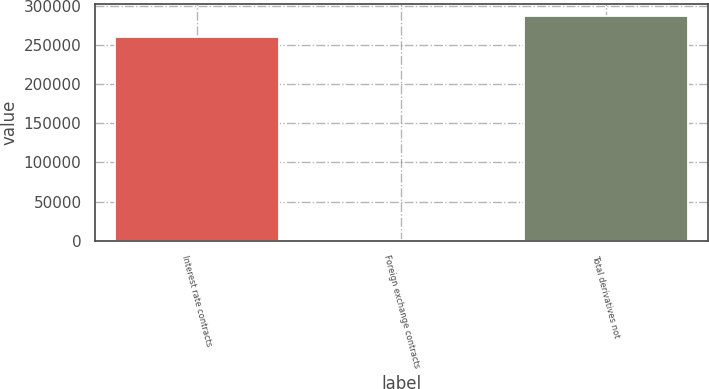<chart> <loc_0><loc_0><loc_500><loc_500><bar_chart><fcel>Interest rate contracts<fcel>Foreign exchange contracts<fcel>Total derivatives not<nl><fcel>261348<fcel>130<fcel>288012<nl></chart> 